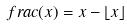Convert formula to latex. <formula><loc_0><loc_0><loc_500><loc_500>f r a c ( x ) = x - \lfloor x \rfloor</formula> 